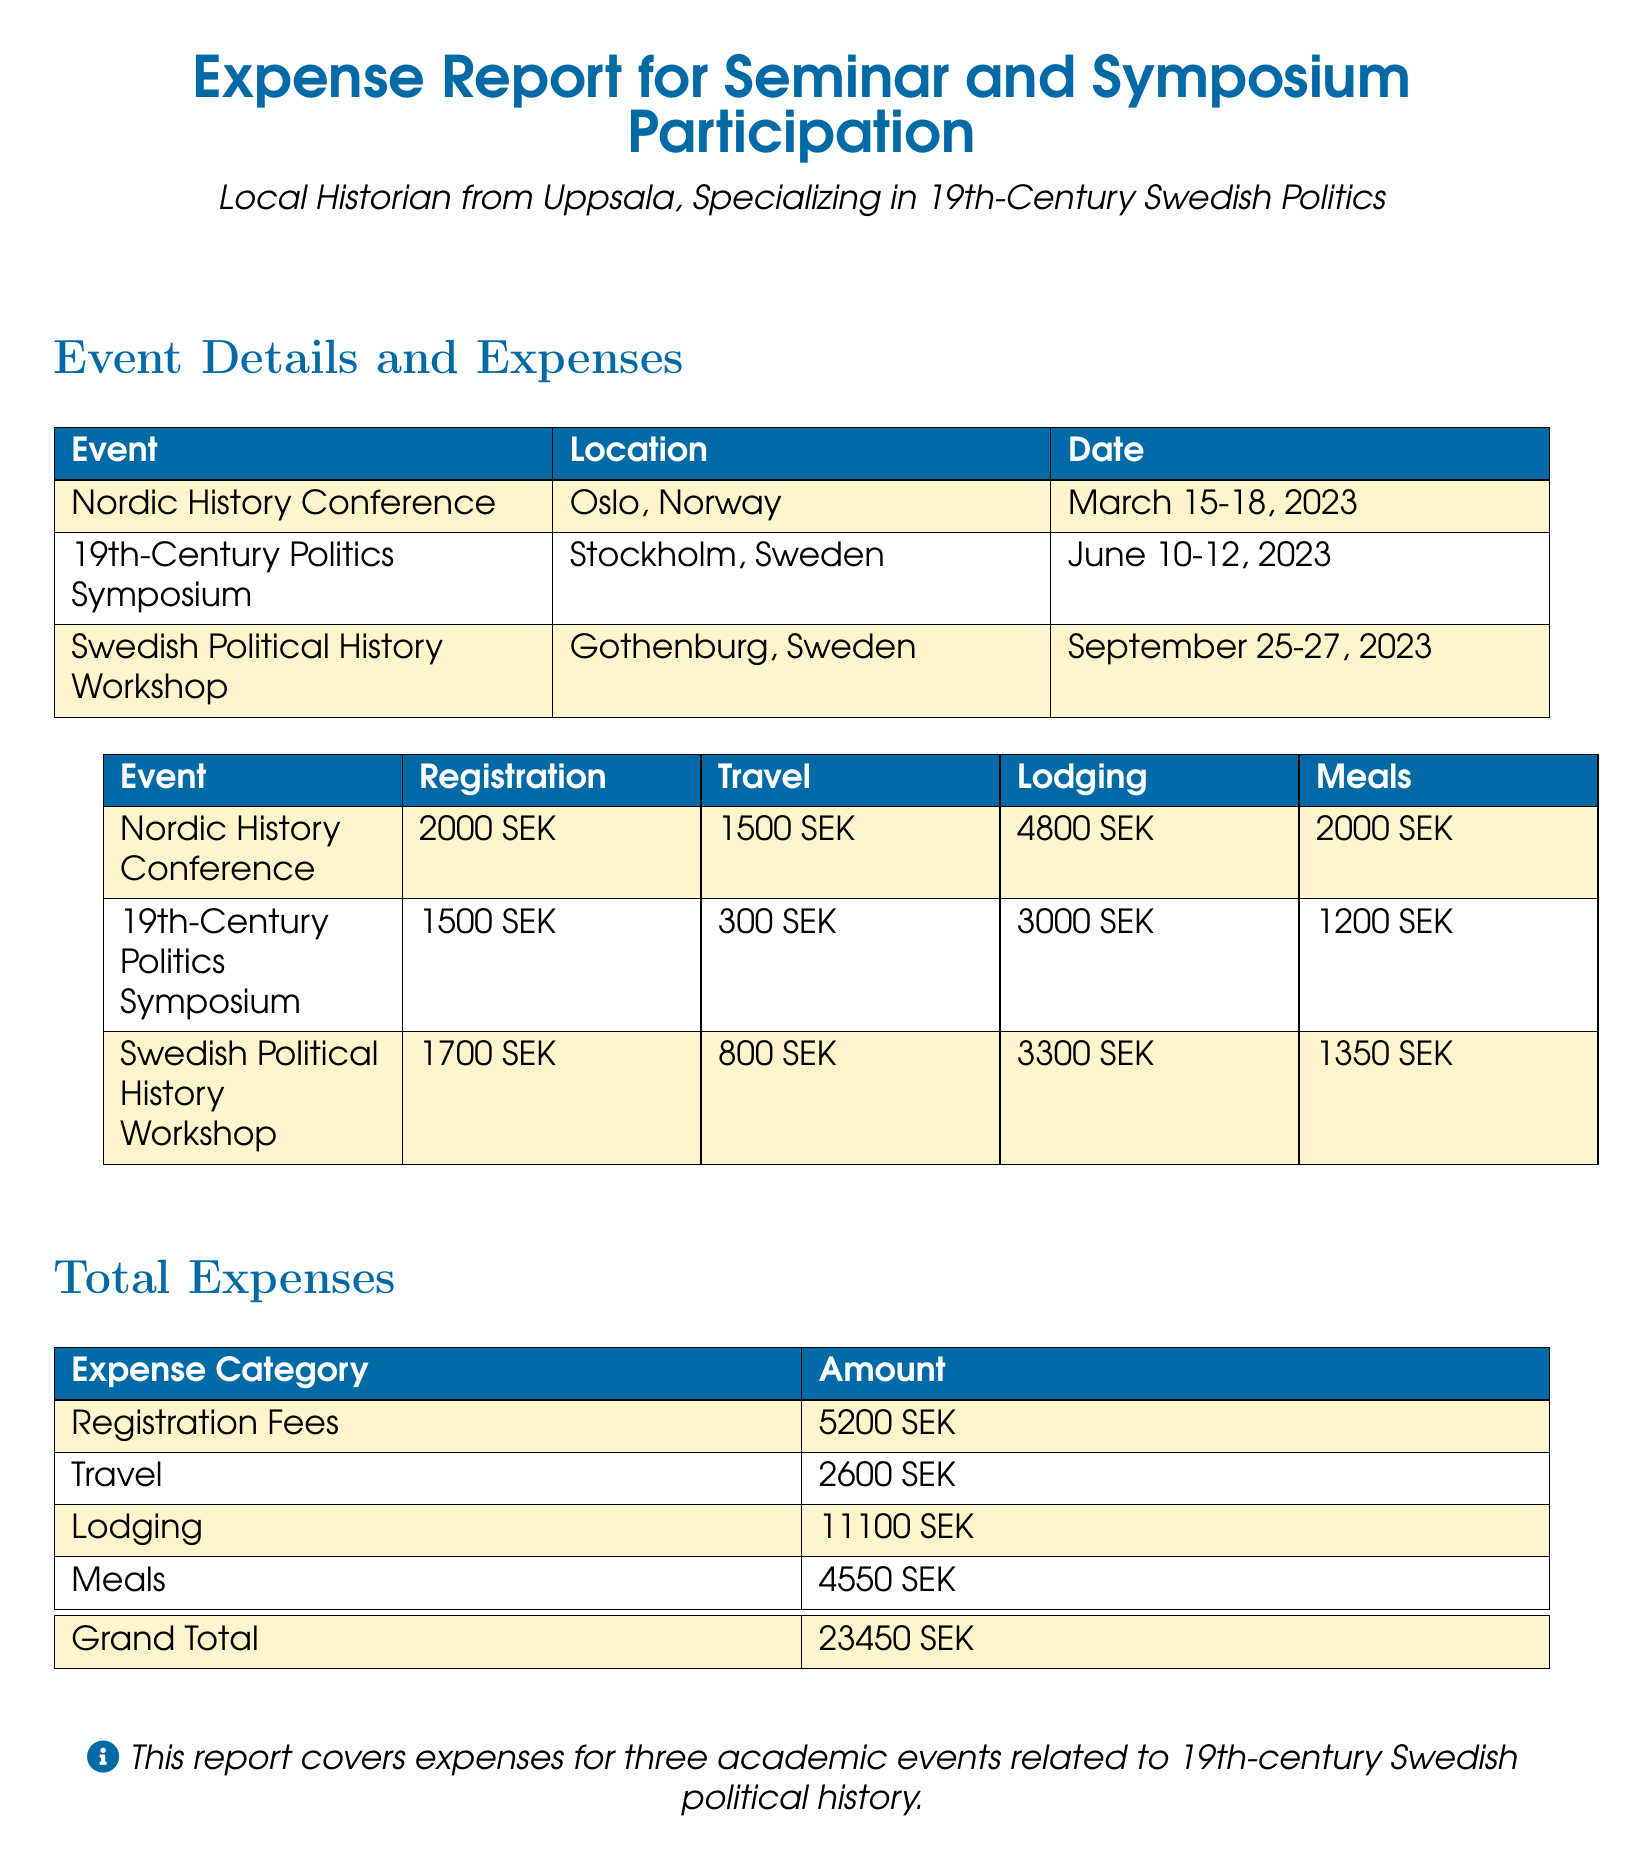What was the registration fee for the Nordic History Conference? The registration fee for the Nordic History Conference is specified in the expenses table.
Answer: 2000 SEK How much was spent on lodging for the 19th-Century Politics Symposium? The lodging expense for the 19th-Century Politics Symposium is listed in the expenses table.
Answer: 3000 SEK What is the date of the Swedish Political History Workshop? The date of the Swedish Political History Workshop can be found in the event details section of the document.
Answer: September 25-27, 2023 What is the total amount spent on meals? The total amount spent on meals is the sum of the meal expenses from all events, found in the totals section.
Answer: 4550 SEK Which event had the highest lodging expense? Comparing lodging expenses from all events will identify the one with the highest expense, presented in the expenses table.
Answer: Swedish Political History Workshop How much was the total expense for travel? The total expense for travel is the sum of all travel expenses, as indicated in the total expenses section.
Answer: 2600 SEK How many events are covered in this report? The report includes a summary of the events listed at the beginning of the document.
Answer: Three What color scheme is used for the headers in the document? The document uses a specific color for the header rows, noted in the table specifications.
Answer: Swedish blue 